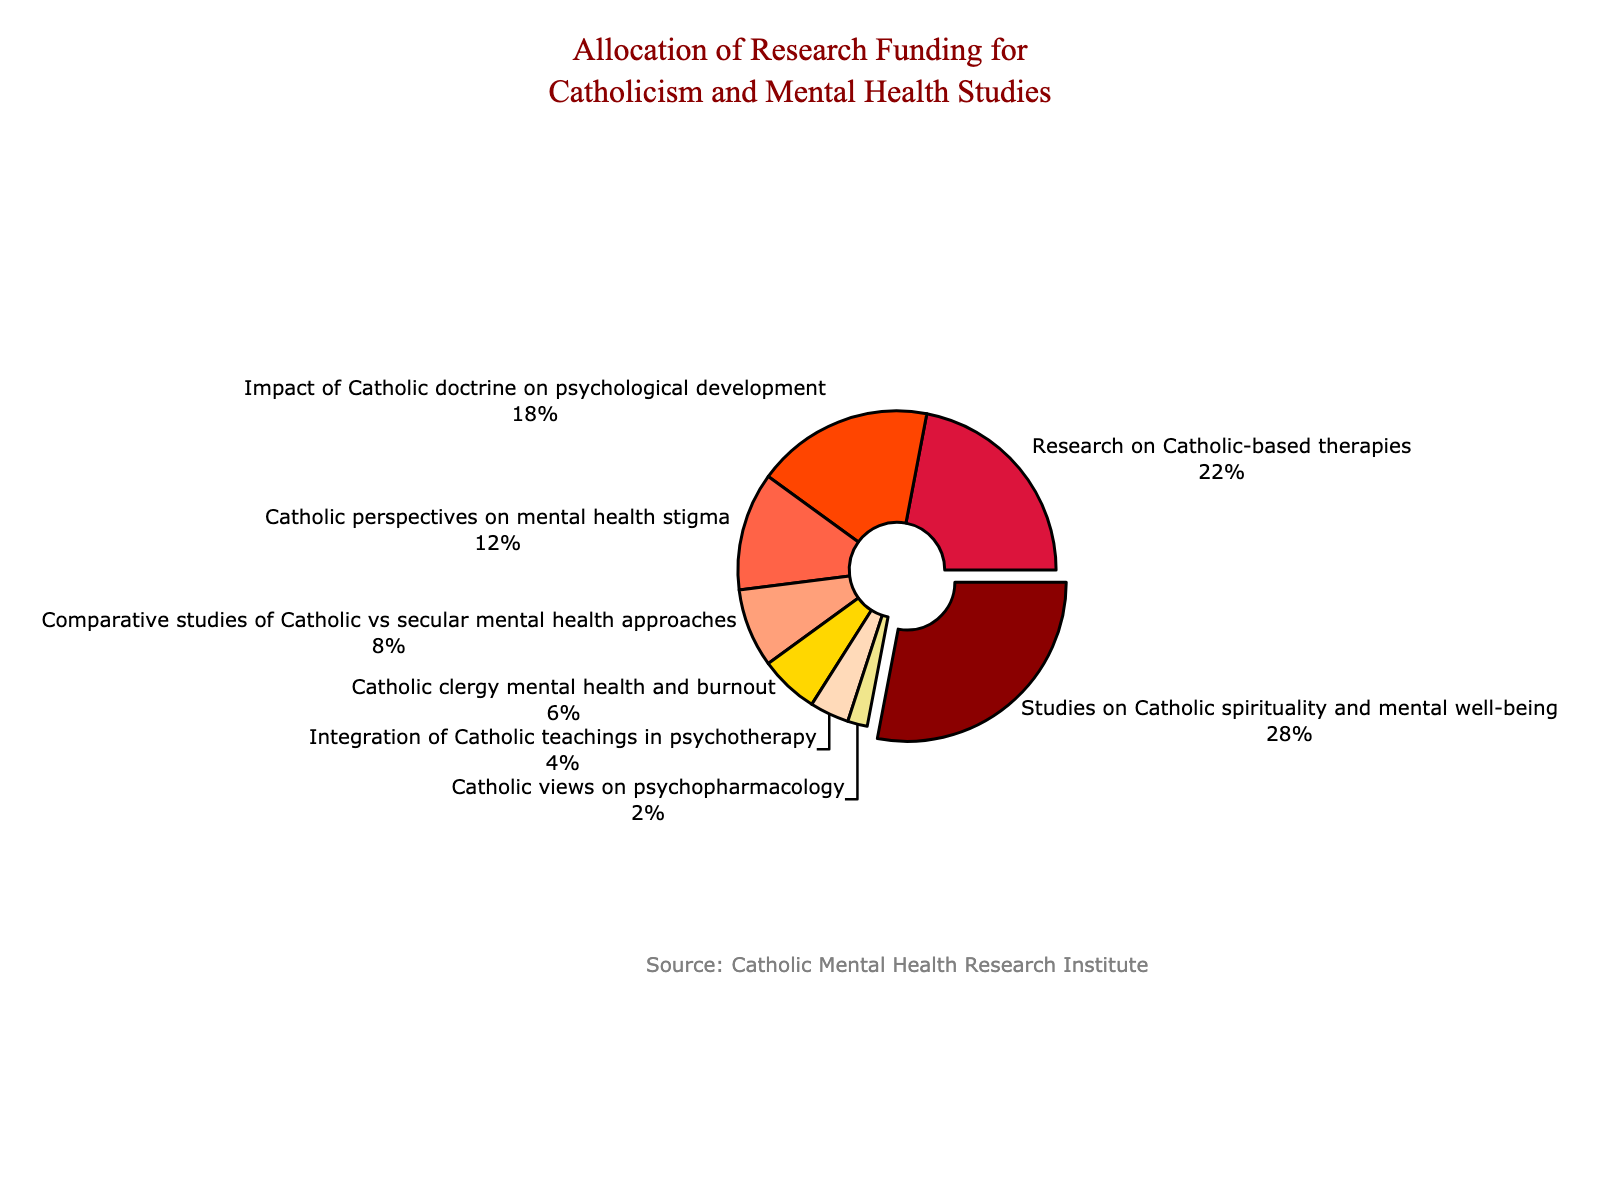What's the largest funding allocation category? The largest funding allocation category is represented by the slice of the pie chart that is pulled out. This slice corresponds to "Studies on Catholic spirituality and mental well-being" which has the largest percentage.
Answer: Studies on Catholic spirituality and mental well-being Which category received the least amount of funding? The pie chart shows the smallest slice represents the category "Catholic views on psychopharmacology," which accounts for the least percentage of the funding.
Answer: Catholic views on psychopharmacology Compare the funding percentages between research on Catholic-based therapies and the impact of Catholic doctrine on psychological development. Which one has a higher percentage and by what difference? Research on Catholic-based therapies received 22% of the funding, while the impact of Catholic doctrine on psychological development got 18%. To find the difference, subtract 18 from 22.
Answer: 4% Calculate the combined percentage of funding allocated to studies on Catholic spirituality and mental well-being and Catholic clergy mental health and burnout. Add the percentages for both categories: 28% (Catholic spirituality and mental well-being) and 6% (Catholic clergy mental health and burnout).
Answer: 34% Which categories combined received over half of the total funding? To find this, add up the percentages starting with the largest until the sum exceeds 50%. The analysis shows that the combined funding for "Studies on Catholic spirituality and mental well-being" (28%) and "Research on Catholic-based therapies" (22%) exceeds half of the total funding (28% + 22% = 50%).
Answer: Studies on Catholic spirituality and mental well-being, Research on Catholic-based therapies Determine the average percentage of funding for all categories mentioned in the pie chart. Add the percentages for all categories and then divide by the number of categories. The sum is 100, and there are 8 categories. Hence, the average is 100/8.
Answer: 12.5% Compare the visual sizes of the slices representing "Comparative studies of Catholic vs secular mental health approaches" and "Integration of Catholic teachings in psychotherapy". Which one is larger? Visually, "Comparative studies of Catholic vs secular mental health approaches" appears larger, representing 8%, compared to "Integration of Catholic teachings in psychotherapy," which represents 4%.
Answer: Comparative studies of Catholic vs secular mental health approaches Find the funding gap between Catholic perspectives on mental health stigma and Catholic views on psychopharmacology. "Catholic perspectives on mental health stigma" received 12%, while "Catholic views on psychopharmacology" received 2%. The difference is obtained by subtracting 2 from 12.
Answer: 10% Which category’s slice is positioned at the top of the pie chart? The pie chart was rotated 90 degrees, placing "Studies on Catholic spirituality and mental well-being" at the top.
Answer: Studies on Catholic spirituality and mental well-being Determine the second smallest funding category and its percentage. By visual inspection, the second smallest slice after "Catholic views on psychopharmacology" (2%) is "Integration of Catholic teachings in psychotherapy" (4%).
Answer: Integration of Catholic teachings in psychotherapy, 4% 